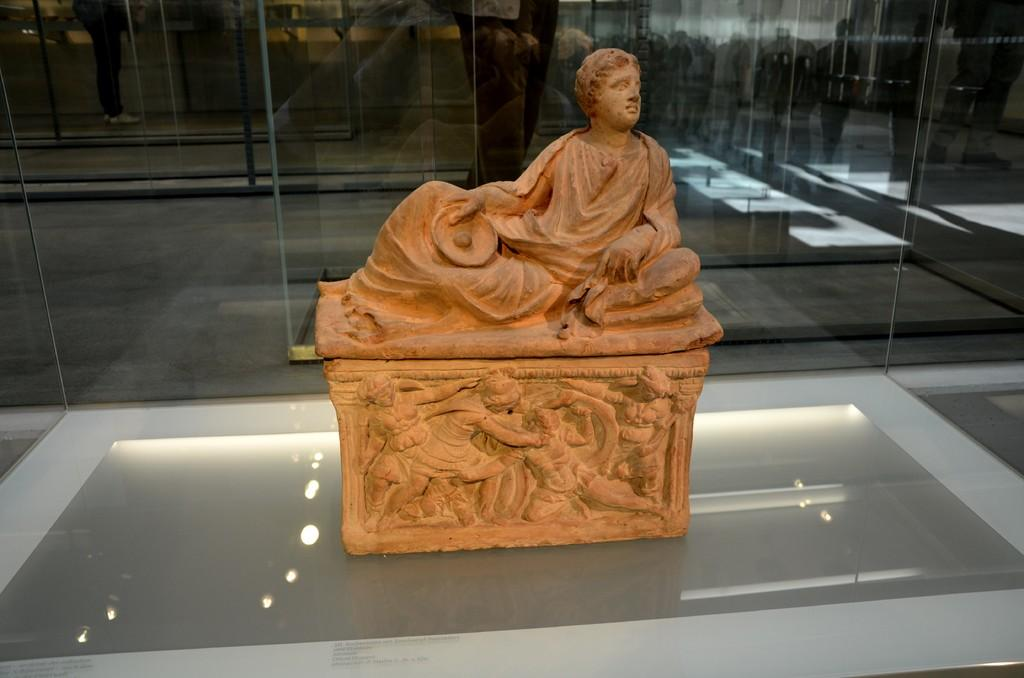What is the main subject in the image? There is a statue in the image. What is located behind the statue in the image? There are glass walls behind the statue in the image. How many sisters does the statue have in the image? There is no reference to any sisters in the image, as it features a statue and glass walls. What type of ticket can be seen in the image? There is no ticket present in the image. 